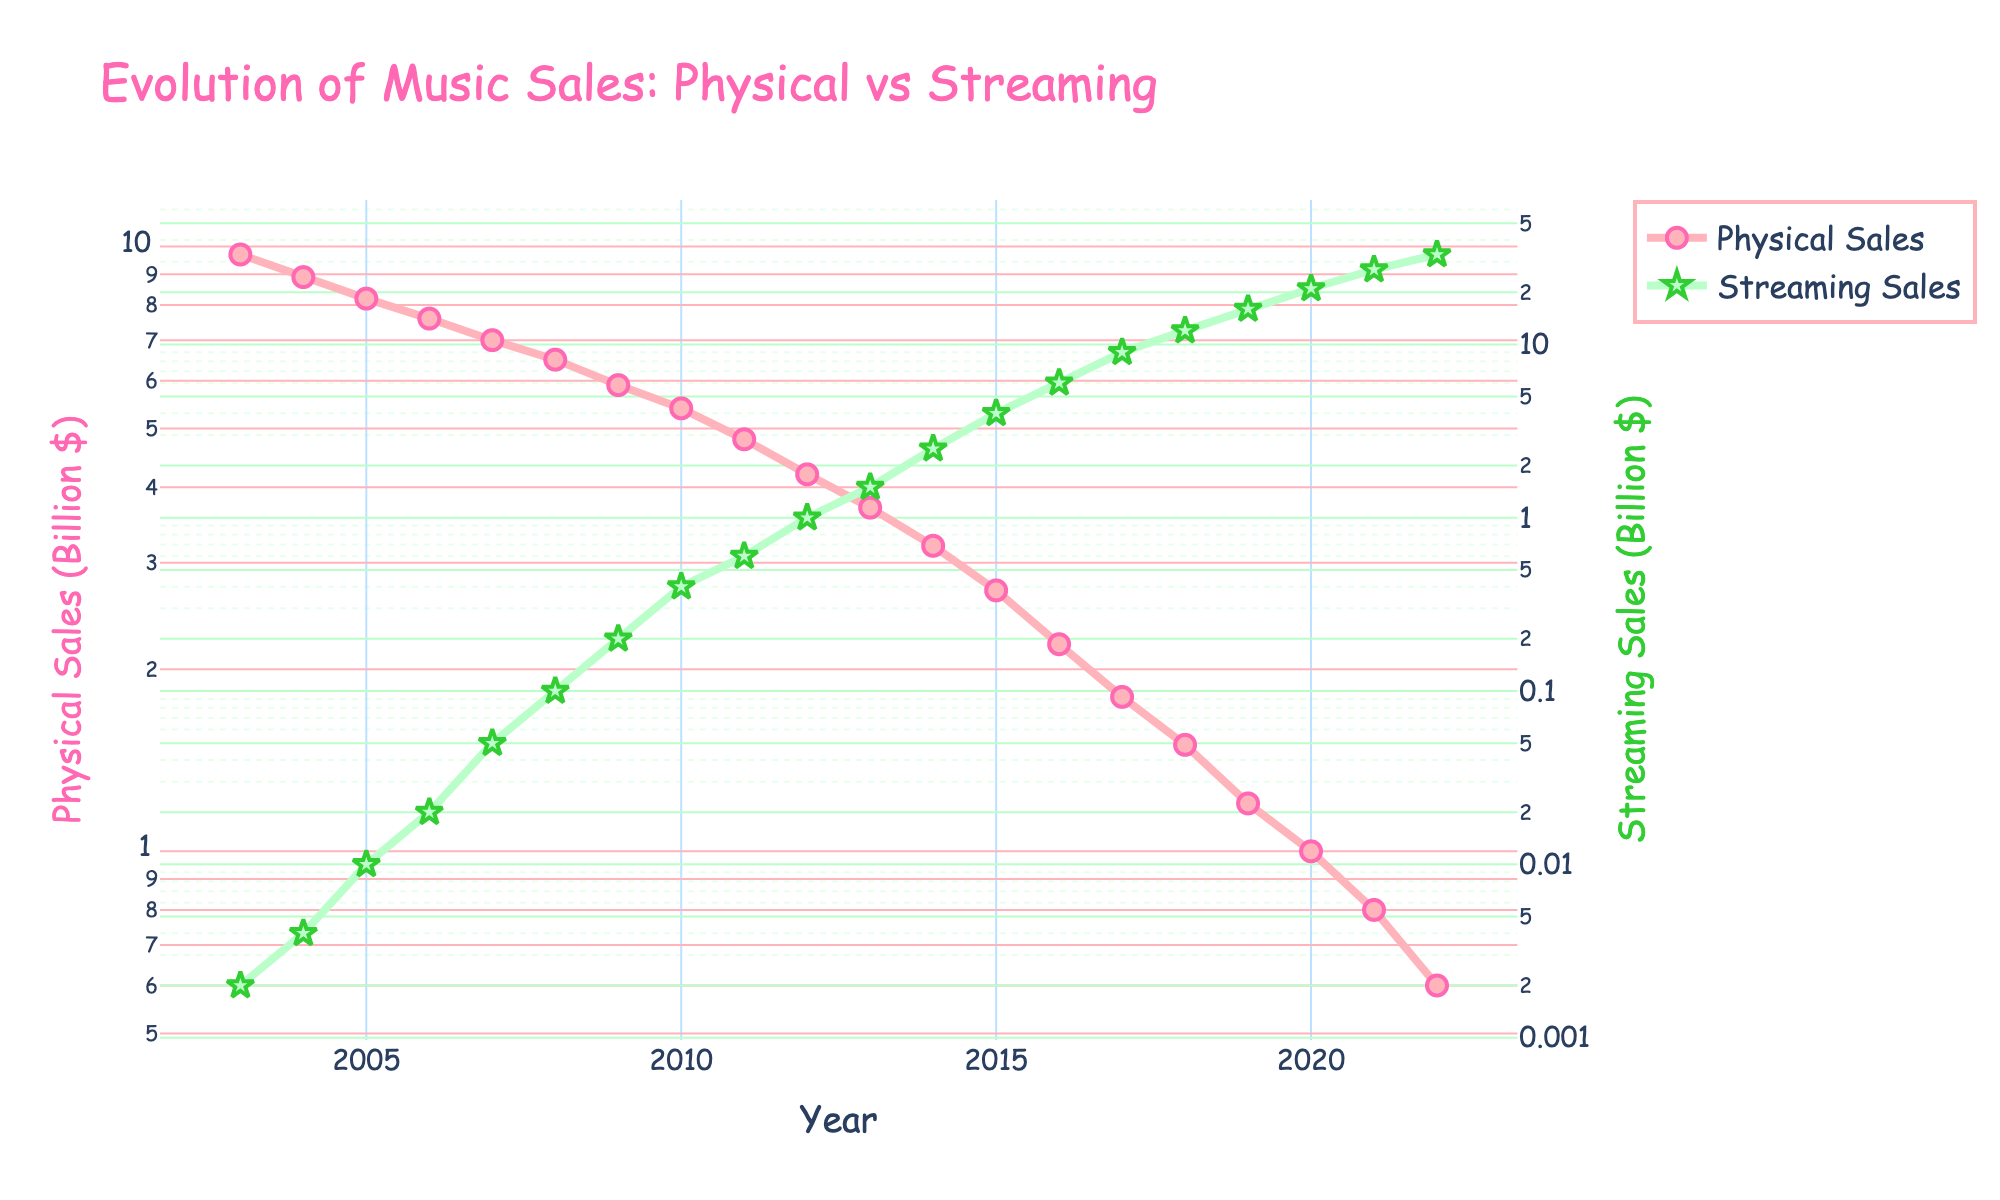What's the title of the plot? The title is located at the top of the figure and provides a summary of what the plot is about.
Answer: Evolution of Music Sales: Physical vs Streaming How many years are represented in the plot? Count the data points along the x-axis, which represent the years. Each point corresponds to one year.
Answer: 20 What is the y-axis type and how does it affect the interpretation? The y-axes are labeled with a logarithmic (log) scale, which means the increments represent exponential growth. This scale is used to visualize a wide range of values more clearly.
Answer: Logarithmic scale Between which years did streaming sales surpass physical sales? Identify the point where the streaming sales curve crosses above the physical sales curve. This can be seen by finding the intersection of the two lines.
Answer: 2012-2013 What was the approximate physical sales value in 2005? Locate the year 2005 on the x-axis and follow it up to the physical sales curve. Then, read off the corresponding y-axis value.
Answer: 8.2 billion dollars How did streaming sales change from 2010 to 2011? Compare the y-axis values for streaming sales in 2010 and 2011. Calculate the difference or growth.
Answer: Increased by 0.2 billion dollars By how much did physical sales decline from 2003 to 2022? Subtract the physical sales value in 2022 from the value in 2003.
Answer: Declined by 9.1 billion dollars What year saw the highest recorded value for streaming sales? Find the peak point on the streaming sales curve and read the corresponding year from the x-axis.
Answer: 2022 When did physical sales first drop below 2 billion dollars? Identify the point where the physical sales curve drops below the 2 billion mark and check the corresponding year on the x-axis.
Answer: 2017 Compare the trends of physical and streaming sales over the 20 years. Observe the overall direction of each line. Physical sales are decreasing while streaming sales are increasing. This trend shows the shift from physical to digital media.
Answer: Physical sales decrease and streaming sales increase 